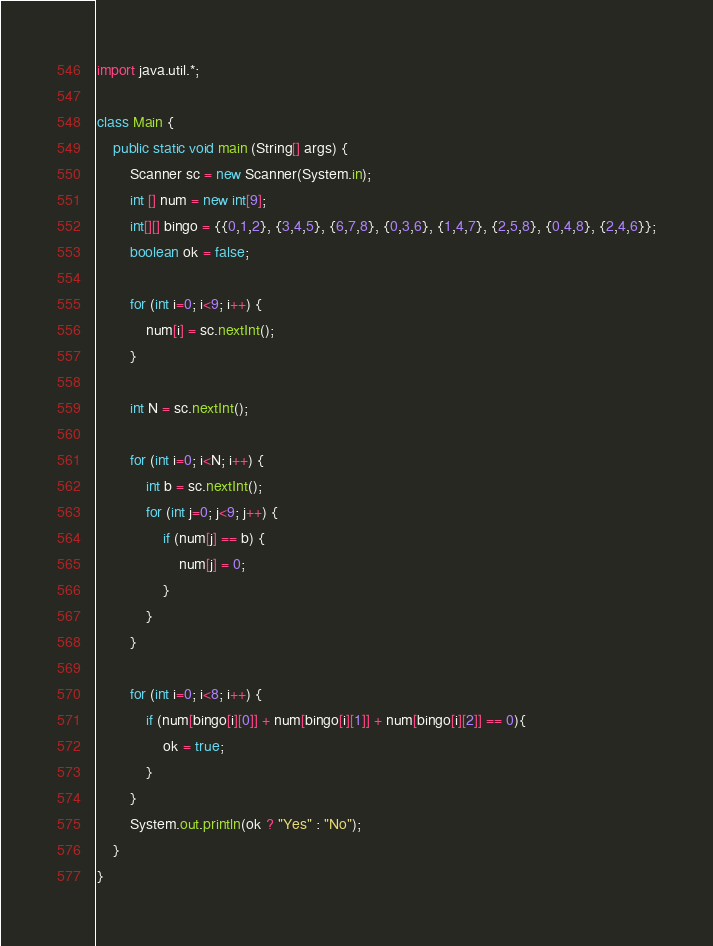Convert code to text. <code><loc_0><loc_0><loc_500><loc_500><_Java_>import java.util.*;

class Main {
	public static void main (String[] args) {
		Scanner sc = new Scanner(System.in);
		int [] num = new int[9];
		int[][] bingo = {{0,1,2}, {3,4,5}, {6,7,8}, {0,3,6}, {1,4,7}, {2,5,8}, {0,4,8}, {2,4,6}};
		boolean ok = false;
		
		for (int i=0; i<9; i++) {
			num[i] = sc.nextInt();
		}
		
		int N = sc.nextInt();
		
		for (int i=0; i<N; i++) {
			int b = sc.nextInt();
			for (int j=0; j<9; j++) {
				if (num[j] == b) {
					num[j] = 0;
				}
			}
		}
		
		for (int i=0; i<8; i++) {
			if (num[bingo[i][0]] + num[bingo[i][1]] + num[bingo[i][2]] == 0){
				ok = true;
			}
		}
		System.out.println(ok ? "Yes" : "No");
	}
}</code> 